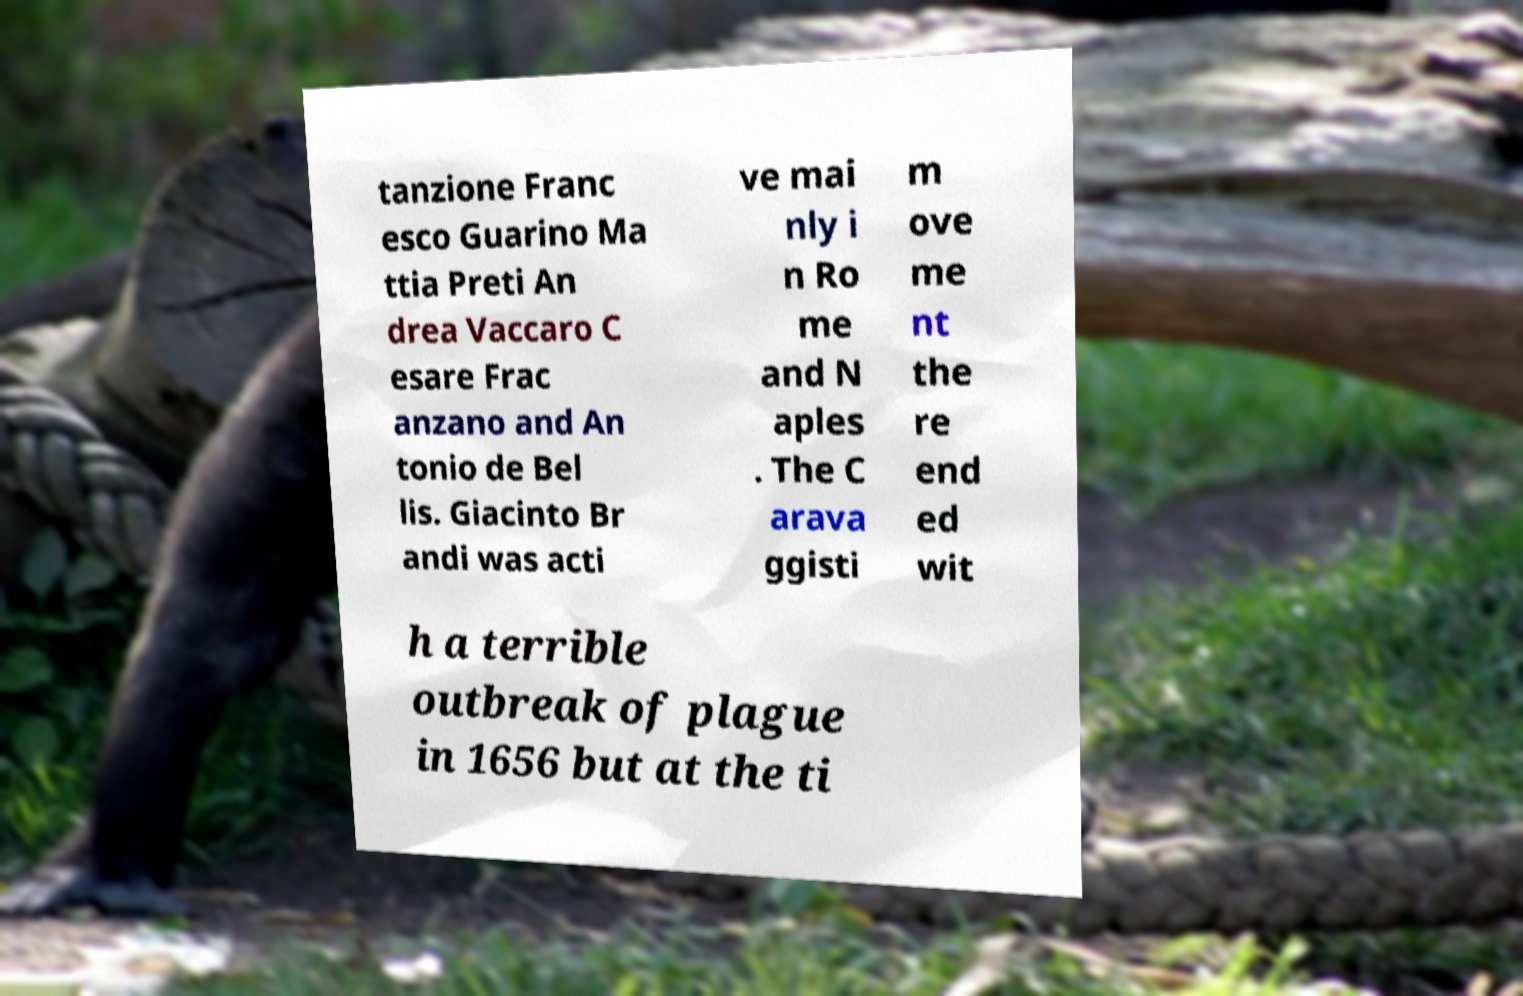There's text embedded in this image that I need extracted. Can you transcribe it verbatim? tanzione Franc esco Guarino Ma ttia Preti An drea Vaccaro C esare Frac anzano and An tonio de Bel lis. Giacinto Br andi was acti ve mai nly i n Ro me and N aples . The C arava ggisti m ove me nt the re end ed wit h a terrible outbreak of plague in 1656 but at the ti 